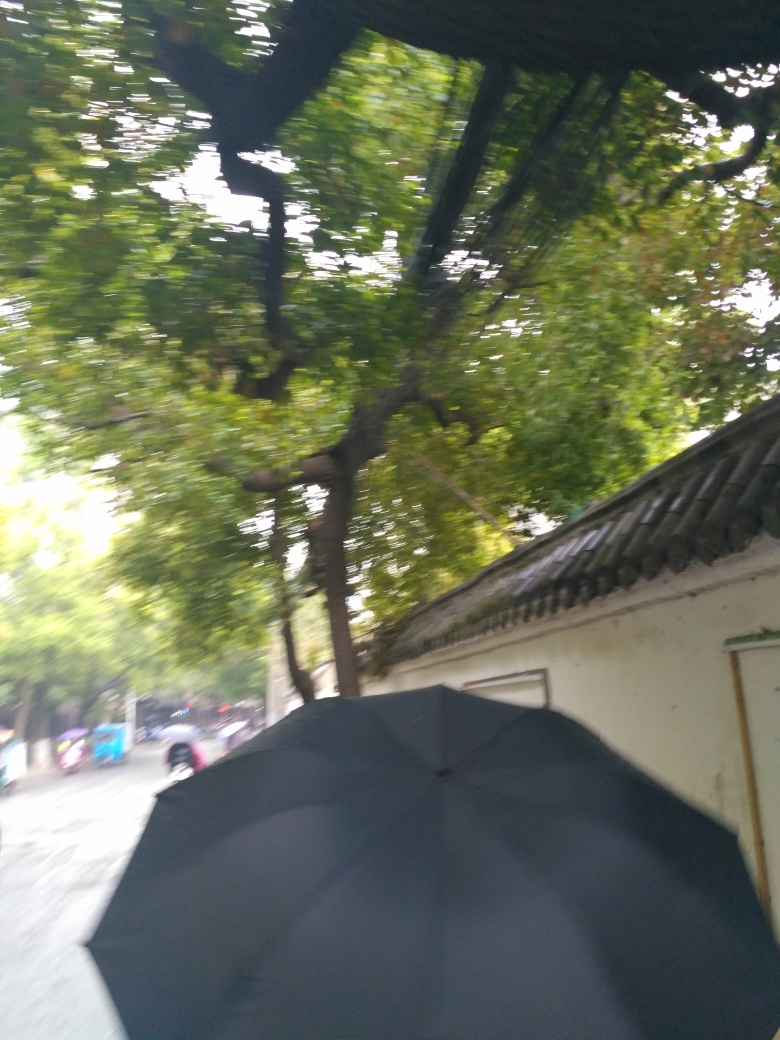How would you describe the motion captured in this image? The blurry nature of the photo conveys a sense of movement, captured imperfectly due to either camera shake or the quick pace of the subject matter, giving the image a dynamic quality. 